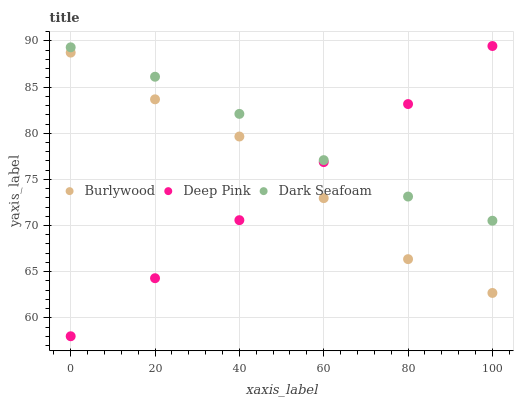Does Deep Pink have the minimum area under the curve?
Answer yes or no. Yes. Does Dark Seafoam have the maximum area under the curve?
Answer yes or no. Yes. Does Dark Seafoam have the minimum area under the curve?
Answer yes or no. No. Does Deep Pink have the maximum area under the curve?
Answer yes or no. No. Is Deep Pink the smoothest?
Answer yes or no. Yes. Is Burlywood the roughest?
Answer yes or no. Yes. Is Dark Seafoam the smoothest?
Answer yes or no. No. Is Dark Seafoam the roughest?
Answer yes or no. No. Does Deep Pink have the lowest value?
Answer yes or no. Yes. Does Dark Seafoam have the lowest value?
Answer yes or no. No. Does Deep Pink have the highest value?
Answer yes or no. Yes. Does Dark Seafoam have the highest value?
Answer yes or no. No. Is Burlywood less than Dark Seafoam?
Answer yes or no. Yes. Is Dark Seafoam greater than Burlywood?
Answer yes or no. Yes. Does Deep Pink intersect Dark Seafoam?
Answer yes or no. Yes. Is Deep Pink less than Dark Seafoam?
Answer yes or no. No. Is Deep Pink greater than Dark Seafoam?
Answer yes or no. No. Does Burlywood intersect Dark Seafoam?
Answer yes or no. No. 